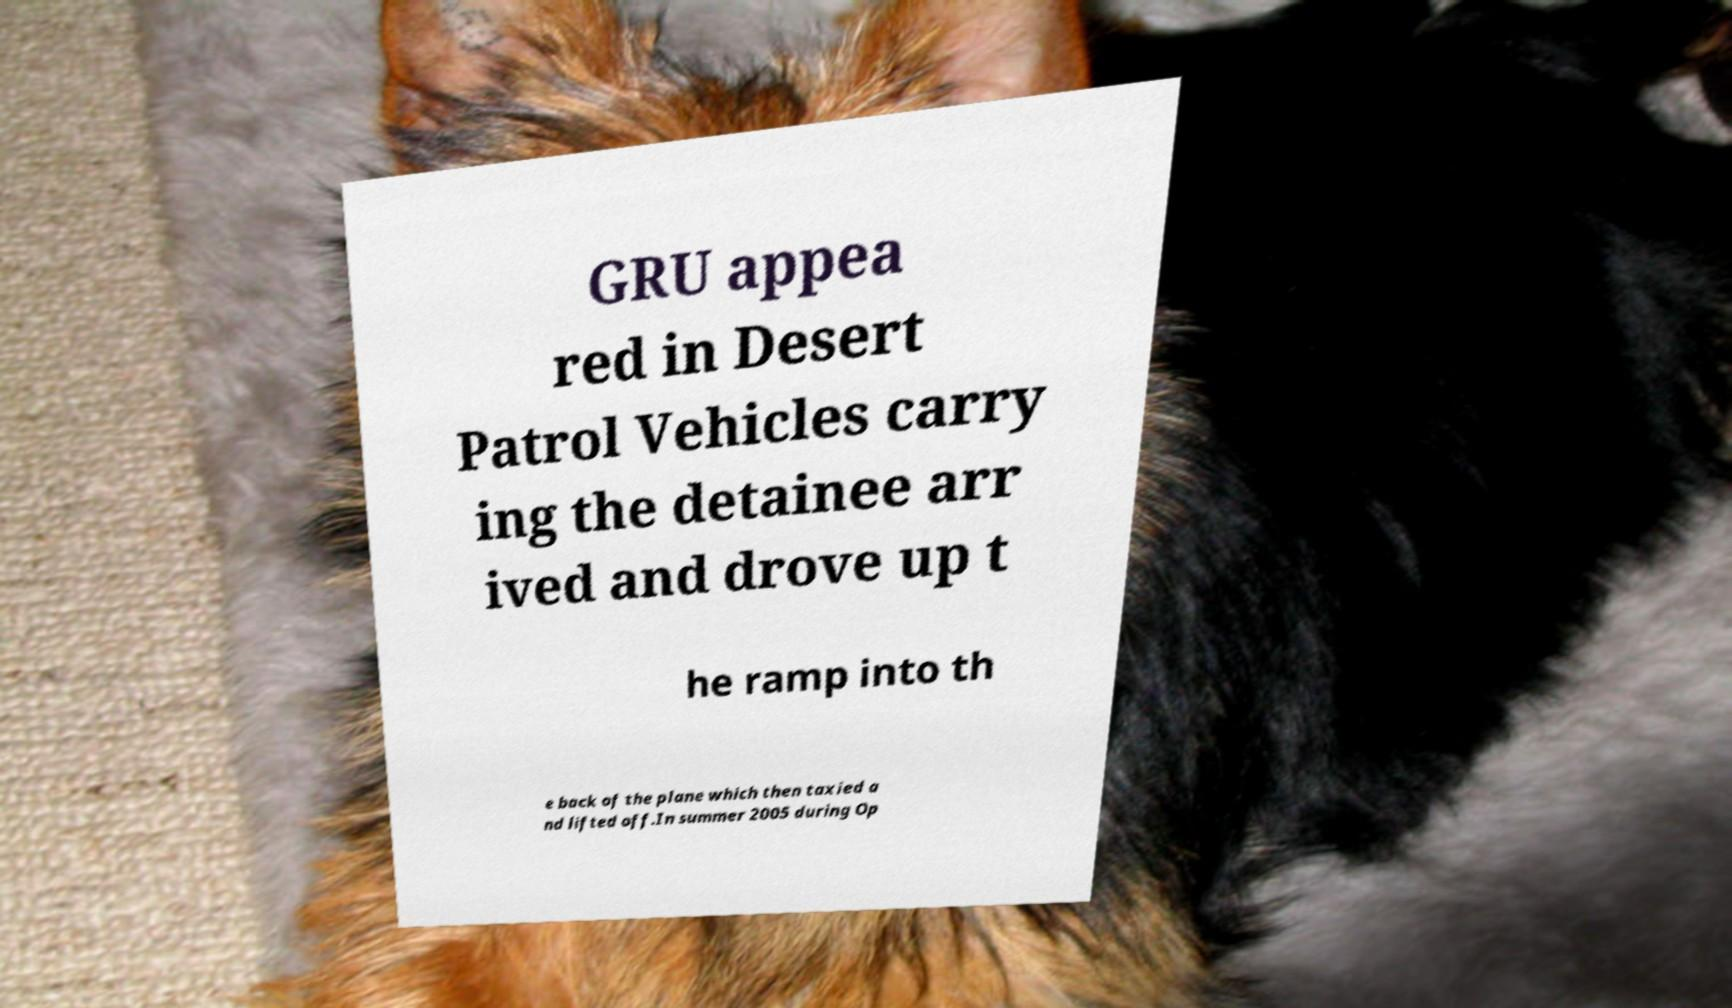Please identify and transcribe the text found in this image. GRU appea red in Desert Patrol Vehicles carry ing the detainee arr ived and drove up t he ramp into th e back of the plane which then taxied a nd lifted off.In summer 2005 during Op 